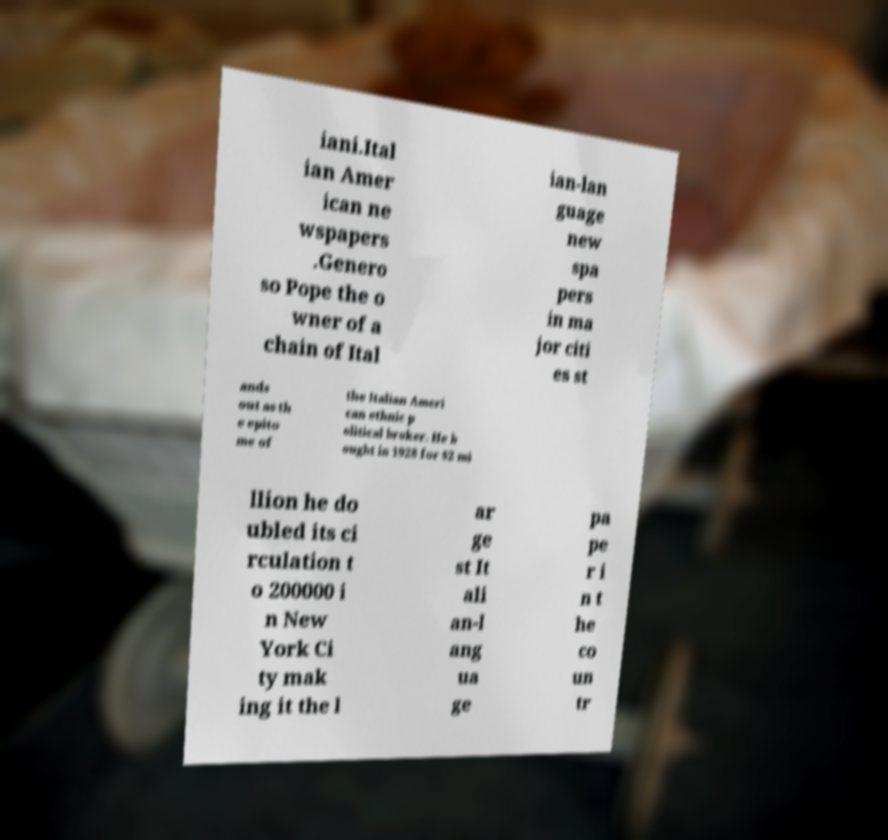Could you extract and type out the text from this image? iani.Ital ian Amer ican ne wspapers .Genero so Pope the o wner of a chain of Ital ian-lan guage new spa pers in ma jor citi es st ands out as th e epito me of the Italian Ameri can ethnic p olitical broker. He b ought in 1928 for $2 mi llion he do ubled its ci rculation t o 200000 i n New York Ci ty mak ing it the l ar ge st It ali an-l ang ua ge pa pe r i n t he co un tr 